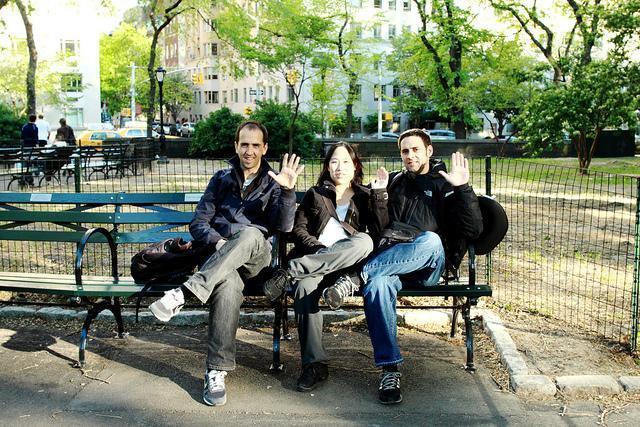How many people only have black shoes?
Give a very brief answer. 2. How many people are in the photo?
Give a very brief answer. 3. 